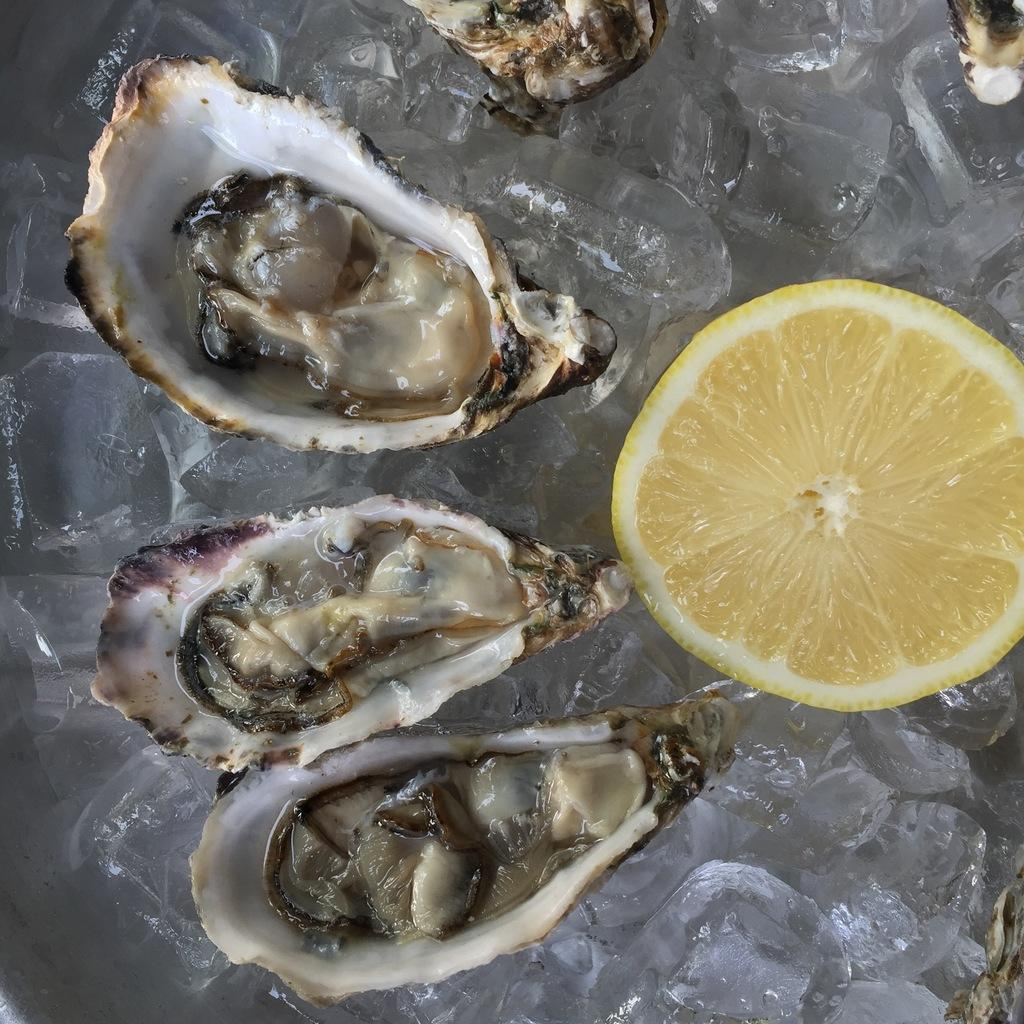What type of food is present in the image? There is seafood in the image. What accompanies the seafood on the plate? There is a lemon in the image. How are the seafood and lemon arranged in the image? The seafood and lemon are on a plate. What can be seen in the background of the image? There is ice in the background of the image. What word is written on the tin in the image? There is no tin present in the image, so it is not possible to answer that question. 